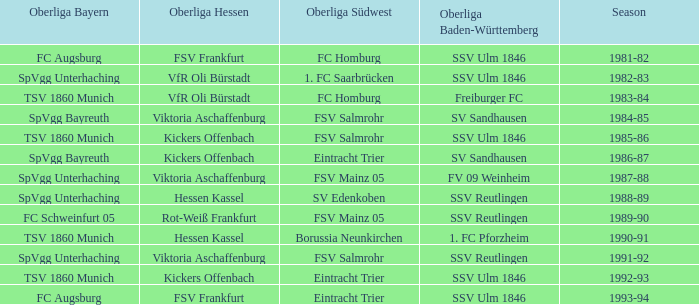Which season has spvgg bayreuth and eintracht trier? 1986-87. 